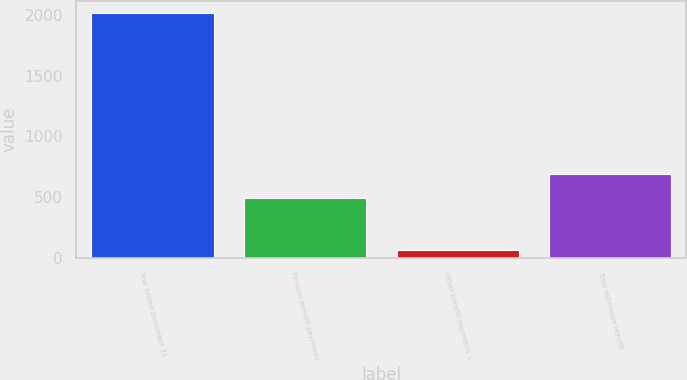<chart> <loc_0><loc_0><loc_500><loc_500><bar_chart><fcel>Year Ended December 31<fcel>Pension benefit payments<fcel>Other benefit payments 1<fcel>Total estimated benefit<nl><fcel>2015<fcel>493<fcel>64<fcel>688.1<nl></chart> 